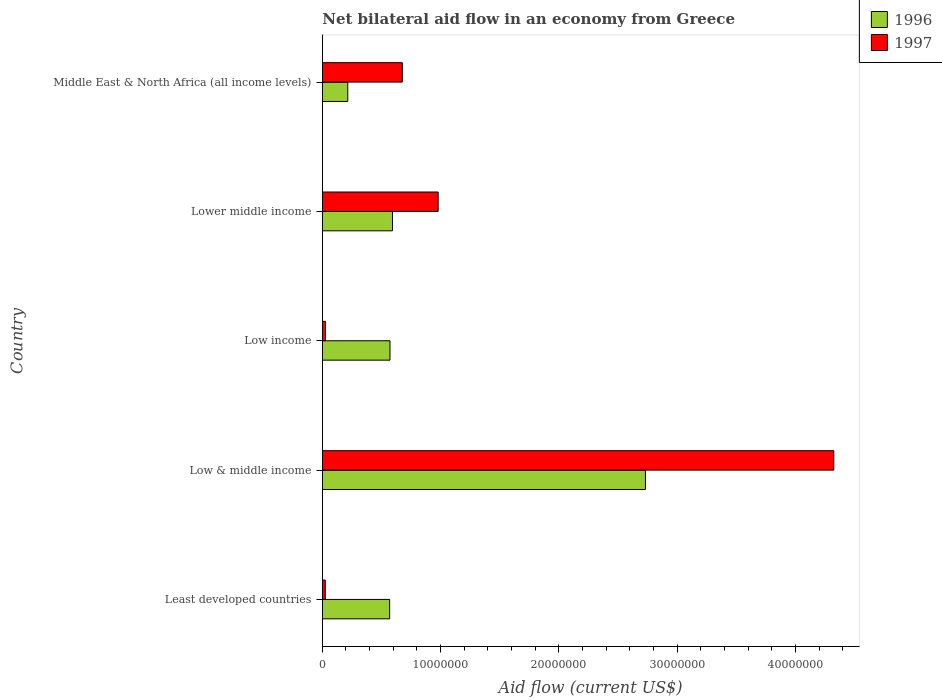What is the label of the 3rd group of bars from the top?
Your answer should be compact. Low income. What is the net bilateral aid flow in 1997 in Middle East & North Africa (all income levels)?
Ensure brevity in your answer.  6.76e+06. Across all countries, what is the maximum net bilateral aid flow in 1996?
Your answer should be very brief. 2.73e+07. Across all countries, what is the minimum net bilateral aid flow in 1997?
Provide a succinct answer. 2.50e+05. In which country was the net bilateral aid flow in 1997 maximum?
Give a very brief answer. Low & middle income. In which country was the net bilateral aid flow in 1996 minimum?
Offer a very short reply. Middle East & North Africa (all income levels). What is the total net bilateral aid flow in 1997 in the graph?
Provide a short and direct response. 6.03e+07. What is the difference between the net bilateral aid flow in 1996 in Low & middle income and that in Lower middle income?
Make the answer very short. 2.14e+07. What is the difference between the net bilateral aid flow in 1996 in Lower middle income and the net bilateral aid flow in 1997 in Middle East & North Africa (all income levels)?
Offer a very short reply. -8.30e+05. What is the average net bilateral aid flow in 1996 per country?
Ensure brevity in your answer.  9.36e+06. What is the difference between the net bilateral aid flow in 1996 and net bilateral aid flow in 1997 in Least developed countries?
Offer a very short reply. 5.44e+06. What is the ratio of the net bilateral aid flow in 1997 in Low & middle income to that in Lower middle income?
Give a very brief answer. 4.42. Is the difference between the net bilateral aid flow in 1996 in Least developed countries and Low income greater than the difference between the net bilateral aid flow in 1997 in Least developed countries and Low income?
Offer a terse response. No. What is the difference between the highest and the second highest net bilateral aid flow in 1996?
Make the answer very short. 2.14e+07. What is the difference between the highest and the lowest net bilateral aid flow in 1996?
Make the answer very short. 2.52e+07. What does the 1st bar from the bottom in Middle East & North Africa (all income levels) represents?
Give a very brief answer. 1996. Are all the bars in the graph horizontal?
Offer a terse response. Yes. How many countries are there in the graph?
Provide a short and direct response. 5. What is the difference between two consecutive major ticks on the X-axis?
Provide a short and direct response. 1.00e+07. Are the values on the major ticks of X-axis written in scientific E-notation?
Your answer should be compact. No. Does the graph contain grids?
Keep it short and to the point. No. How many legend labels are there?
Give a very brief answer. 2. What is the title of the graph?
Give a very brief answer. Net bilateral aid flow in an economy from Greece. What is the Aid flow (current US$) of 1996 in Least developed countries?
Give a very brief answer. 5.69e+06. What is the Aid flow (current US$) of 1997 in Least developed countries?
Provide a succinct answer. 2.50e+05. What is the Aid flow (current US$) in 1996 in Low & middle income?
Give a very brief answer. 2.73e+07. What is the Aid flow (current US$) of 1997 in Low & middle income?
Give a very brief answer. 4.32e+07. What is the Aid flow (current US$) in 1996 in Low income?
Offer a terse response. 5.72e+06. What is the Aid flow (current US$) in 1997 in Low income?
Your response must be concise. 2.70e+05. What is the Aid flow (current US$) in 1996 in Lower middle income?
Your answer should be compact. 5.93e+06. What is the Aid flow (current US$) in 1997 in Lower middle income?
Provide a succinct answer. 9.79e+06. What is the Aid flow (current US$) of 1996 in Middle East & North Africa (all income levels)?
Your answer should be compact. 2.15e+06. What is the Aid flow (current US$) of 1997 in Middle East & North Africa (all income levels)?
Offer a very short reply. 6.76e+06. Across all countries, what is the maximum Aid flow (current US$) in 1996?
Provide a short and direct response. 2.73e+07. Across all countries, what is the maximum Aid flow (current US$) of 1997?
Provide a short and direct response. 4.32e+07. Across all countries, what is the minimum Aid flow (current US$) in 1996?
Your answer should be compact. 2.15e+06. Across all countries, what is the minimum Aid flow (current US$) of 1997?
Ensure brevity in your answer.  2.50e+05. What is the total Aid flow (current US$) in 1996 in the graph?
Make the answer very short. 4.68e+07. What is the total Aid flow (current US$) in 1997 in the graph?
Your response must be concise. 6.03e+07. What is the difference between the Aid flow (current US$) of 1996 in Least developed countries and that in Low & middle income?
Keep it short and to the point. -2.16e+07. What is the difference between the Aid flow (current US$) in 1997 in Least developed countries and that in Low & middle income?
Offer a very short reply. -4.30e+07. What is the difference between the Aid flow (current US$) of 1996 in Least developed countries and that in Low income?
Keep it short and to the point. -3.00e+04. What is the difference between the Aid flow (current US$) in 1997 in Least developed countries and that in Lower middle income?
Give a very brief answer. -9.54e+06. What is the difference between the Aid flow (current US$) of 1996 in Least developed countries and that in Middle East & North Africa (all income levels)?
Offer a terse response. 3.54e+06. What is the difference between the Aid flow (current US$) of 1997 in Least developed countries and that in Middle East & North Africa (all income levels)?
Ensure brevity in your answer.  -6.51e+06. What is the difference between the Aid flow (current US$) of 1996 in Low & middle income and that in Low income?
Provide a succinct answer. 2.16e+07. What is the difference between the Aid flow (current US$) of 1997 in Low & middle income and that in Low income?
Keep it short and to the point. 4.30e+07. What is the difference between the Aid flow (current US$) of 1996 in Low & middle income and that in Lower middle income?
Provide a short and direct response. 2.14e+07. What is the difference between the Aid flow (current US$) in 1997 in Low & middle income and that in Lower middle income?
Make the answer very short. 3.34e+07. What is the difference between the Aid flow (current US$) in 1996 in Low & middle income and that in Middle East & North Africa (all income levels)?
Offer a terse response. 2.52e+07. What is the difference between the Aid flow (current US$) in 1997 in Low & middle income and that in Middle East & North Africa (all income levels)?
Make the answer very short. 3.65e+07. What is the difference between the Aid flow (current US$) in 1997 in Low income and that in Lower middle income?
Offer a very short reply. -9.52e+06. What is the difference between the Aid flow (current US$) of 1996 in Low income and that in Middle East & North Africa (all income levels)?
Make the answer very short. 3.57e+06. What is the difference between the Aid flow (current US$) in 1997 in Low income and that in Middle East & North Africa (all income levels)?
Provide a succinct answer. -6.49e+06. What is the difference between the Aid flow (current US$) in 1996 in Lower middle income and that in Middle East & North Africa (all income levels)?
Ensure brevity in your answer.  3.78e+06. What is the difference between the Aid flow (current US$) in 1997 in Lower middle income and that in Middle East & North Africa (all income levels)?
Your response must be concise. 3.03e+06. What is the difference between the Aid flow (current US$) of 1996 in Least developed countries and the Aid flow (current US$) of 1997 in Low & middle income?
Your answer should be compact. -3.75e+07. What is the difference between the Aid flow (current US$) of 1996 in Least developed countries and the Aid flow (current US$) of 1997 in Low income?
Your answer should be very brief. 5.42e+06. What is the difference between the Aid flow (current US$) in 1996 in Least developed countries and the Aid flow (current US$) in 1997 in Lower middle income?
Give a very brief answer. -4.10e+06. What is the difference between the Aid flow (current US$) in 1996 in Least developed countries and the Aid flow (current US$) in 1997 in Middle East & North Africa (all income levels)?
Offer a very short reply. -1.07e+06. What is the difference between the Aid flow (current US$) in 1996 in Low & middle income and the Aid flow (current US$) in 1997 in Low income?
Your response must be concise. 2.70e+07. What is the difference between the Aid flow (current US$) in 1996 in Low & middle income and the Aid flow (current US$) in 1997 in Lower middle income?
Your answer should be very brief. 1.75e+07. What is the difference between the Aid flow (current US$) in 1996 in Low & middle income and the Aid flow (current US$) in 1997 in Middle East & North Africa (all income levels)?
Your answer should be compact. 2.06e+07. What is the difference between the Aid flow (current US$) in 1996 in Low income and the Aid flow (current US$) in 1997 in Lower middle income?
Offer a very short reply. -4.07e+06. What is the difference between the Aid flow (current US$) in 1996 in Low income and the Aid flow (current US$) in 1997 in Middle East & North Africa (all income levels)?
Make the answer very short. -1.04e+06. What is the difference between the Aid flow (current US$) of 1996 in Lower middle income and the Aid flow (current US$) of 1997 in Middle East & North Africa (all income levels)?
Provide a short and direct response. -8.30e+05. What is the average Aid flow (current US$) in 1996 per country?
Keep it short and to the point. 9.36e+06. What is the average Aid flow (current US$) in 1997 per country?
Offer a very short reply. 1.21e+07. What is the difference between the Aid flow (current US$) in 1996 and Aid flow (current US$) in 1997 in Least developed countries?
Your answer should be compact. 5.44e+06. What is the difference between the Aid flow (current US$) in 1996 and Aid flow (current US$) in 1997 in Low & middle income?
Keep it short and to the point. -1.59e+07. What is the difference between the Aid flow (current US$) in 1996 and Aid flow (current US$) in 1997 in Low income?
Your response must be concise. 5.45e+06. What is the difference between the Aid flow (current US$) of 1996 and Aid flow (current US$) of 1997 in Lower middle income?
Provide a short and direct response. -3.86e+06. What is the difference between the Aid flow (current US$) of 1996 and Aid flow (current US$) of 1997 in Middle East & North Africa (all income levels)?
Give a very brief answer. -4.61e+06. What is the ratio of the Aid flow (current US$) in 1996 in Least developed countries to that in Low & middle income?
Your answer should be compact. 0.21. What is the ratio of the Aid flow (current US$) in 1997 in Least developed countries to that in Low & middle income?
Offer a terse response. 0.01. What is the ratio of the Aid flow (current US$) of 1996 in Least developed countries to that in Low income?
Provide a short and direct response. 0.99. What is the ratio of the Aid flow (current US$) in 1997 in Least developed countries to that in Low income?
Give a very brief answer. 0.93. What is the ratio of the Aid flow (current US$) of 1996 in Least developed countries to that in Lower middle income?
Your answer should be compact. 0.96. What is the ratio of the Aid flow (current US$) in 1997 in Least developed countries to that in Lower middle income?
Make the answer very short. 0.03. What is the ratio of the Aid flow (current US$) in 1996 in Least developed countries to that in Middle East & North Africa (all income levels)?
Offer a terse response. 2.65. What is the ratio of the Aid flow (current US$) of 1997 in Least developed countries to that in Middle East & North Africa (all income levels)?
Ensure brevity in your answer.  0.04. What is the ratio of the Aid flow (current US$) of 1996 in Low & middle income to that in Low income?
Your answer should be very brief. 4.77. What is the ratio of the Aid flow (current US$) of 1997 in Low & middle income to that in Low income?
Ensure brevity in your answer.  160.11. What is the ratio of the Aid flow (current US$) in 1996 in Low & middle income to that in Lower middle income?
Offer a terse response. 4.61. What is the ratio of the Aid flow (current US$) of 1997 in Low & middle income to that in Lower middle income?
Your answer should be very brief. 4.42. What is the ratio of the Aid flow (current US$) in 1996 in Low & middle income to that in Middle East & North Africa (all income levels)?
Ensure brevity in your answer.  12.7. What is the ratio of the Aid flow (current US$) in 1997 in Low & middle income to that in Middle East & North Africa (all income levels)?
Provide a succinct answer. 6.39. What is the ratio of the Aid flow (current US$) of 1996 in Low income to that in Lower middle income?
Your answer should be very brief. 0.96. What is the ratio of the Aid flow (current US$) of 1997 in Low income to that in Lower middle income?
Keep it short and to the point. 0.03. What is the ratio of the Aid flow (current US$) of 1996 in Low income to that in Middle East & North Africa (all income levels)?
Offer a very short reply. 2.66. What is the ratio of the Aid flow (current US$) in 1997 in Low income to that in Middle East & North Africa (all income levels)?
Provide a short and direct response. 0.04. What is the ratio of the Aid flow (current US$) of 1996 in Lower middle income to that in Middle East & North Africa (all income levels)?
Ensure brevity in your answer.  2.76. What is the ratio of the Aid flow (current US$) in 1997 in Lower middle income to that in Middle East & North Africa (all income levels)?
Offer a terse response. 1.45. What is the difference between the highest and the second highest Aid flow (current US$) in 1996?
Offer a very short reply. 2.14e+07. What is the difference between the highest and the second highest Aid flow (current US$) of 1997?
Keep it short and to the point. 3.34e+07. What is the difference between the highest and the lowest Aid flow (current US$) in 1996?
Make the answer very short. 2.52e+07. What is the difference between the highest and the lowest Aid flow (current US$) in 1997?
Provide a short and direct response. 4.30e+07. 